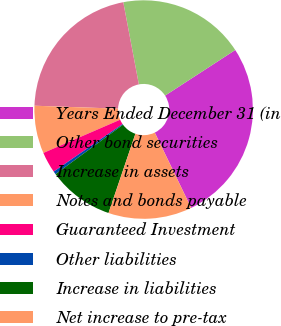Convert chart. <chart><loc_0><loc_0><loc_500><loc_500><pie_chart><fcel>Years Ended December 31 (in<fcel>Other bond securities<fcel>Increase in assets<fcel>Notes and bonds payable<fcel>Guaranteed Investment<fcel>Other liabilities<fcel>Increase in liabilities<fcel>Net increase to pre-tax<nl><fcel>27.01%<fcel>18.81%<fcel>21.46%<fcel>7.06%<fcel>3.11%<fcel>0.46%<fcel>9.72%<fcel>12.37%<nl></chart> 